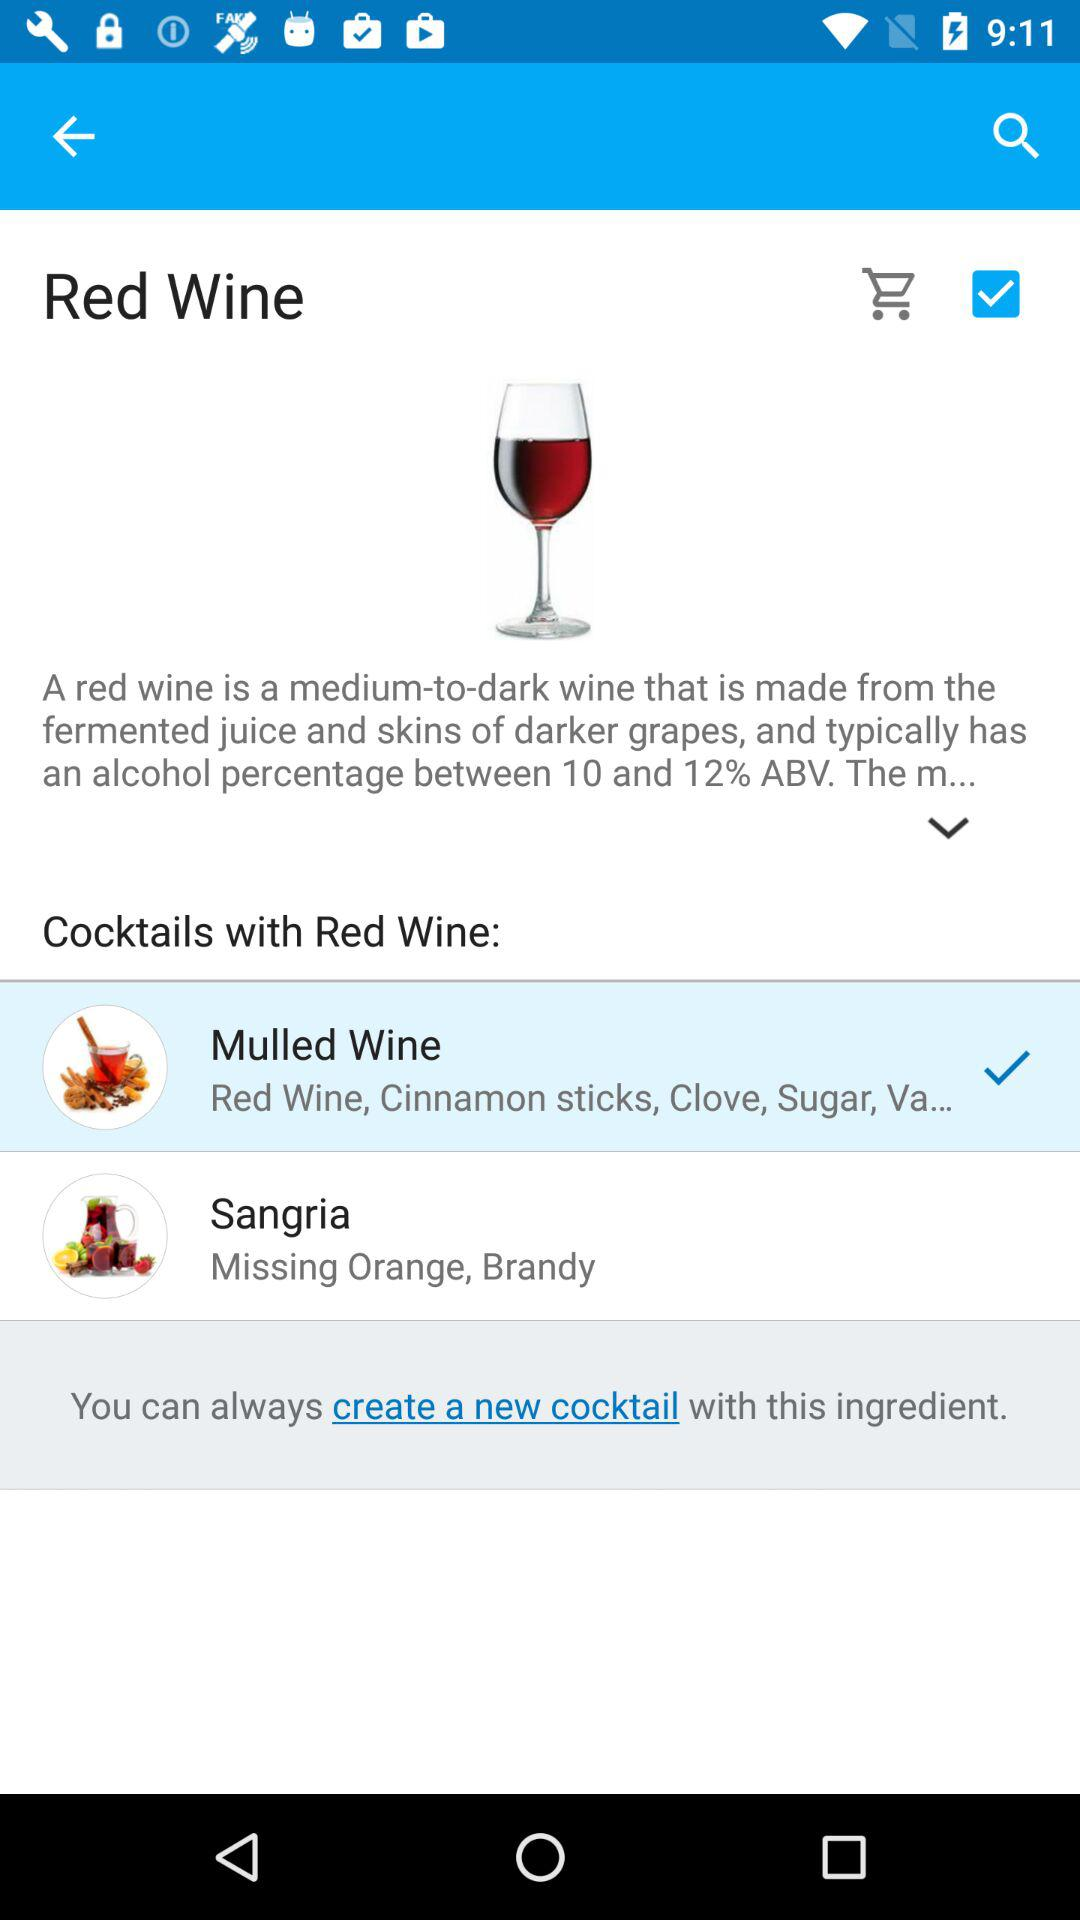What's the status of "Red Wine"? The status is "on". 